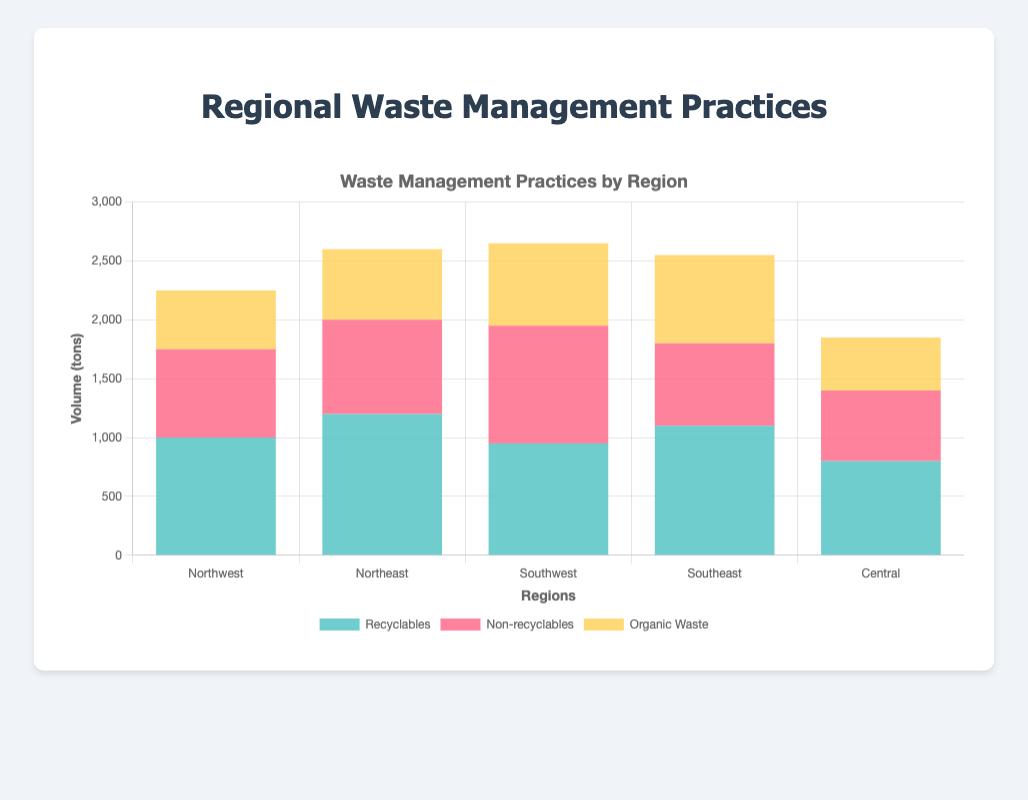Which region has the highest volume of recyclables? The Northeast region has the highest volume of recyclables. This can be seen by comparing the height of the sections colored for recyclables in each bar, with the Northeast having the tallest section.
Answer: Northeast Which region has the lowest volume of non-recyclables? The Central region has the lowest volume of non-recyclables. This is observed by noting that the section colored for non-recyclables in the Central region is shorter than in other regions.
Answer: Central What is the total volume of waste (all types) in the Southwest region? In the Southwest region, the total volume is computed as follows: Recyclables (950 tons) + Non-recyclables (1000 tons) + Organic Waste (700 tons) = 2650 tons.
Answer: 2650 tons How much more recyclables volume is there in the Northeast compared to the Central region? The volume of recyclables in the Northeast is 1200 tons, and in the Central region, it is 800 tons. Therefore, the difference is 1200 - 800 = 400 tons.
Answer: 400 tons Which region has the highest total volume of organic waste, and what is that volume? The Southeast region has the highest volume of organic waste, which is observed by the height of the organic waste section, and it is 750 tons.
Answer: Southeast, 750 tons Compare the volume of non-recyclables in the Northwest and Southwest regions. Which one is higher and by how much? The volume of non-recyclables in the Northwest is 750 tons, and in the Southwest, it is 1000 tons. The Southwest has a higher volume by 1000 - 750 = 250 tons.
Answer: Southwest, 250 tons What is the average volume of organic waste across all regions? The volumes of organic waste are: 500 (Northwest), 600 (Northeast), 700 (Southwest), 750 (Southeast), and 450 (Central). The total is 500+600+700+750+450 = 3000 tons, so the average is 3000 / 5 = 600 tons.
Answer: 600 tons Between which two regions is the total waste volume the most similar, and what are their respective volumes? The most similar total waste volumes are in the Northwest (1000+750+500 = 2250 tons) and the Southeast (1100+700+750 = 2550 tons). The difference is 2550 - 2250 = 300 tons, the smallest difference when comparing all pairs.
Answer: Northwest (2250 tons) and Southeast (2550 tons) What is the difference in total waste volume between the highest and the lowest generating regions? The highest volume is in the Southeast (2550 tons), and the lowest is in the Central (1850 tons). The difference is 2550 - 1850 = 700 tons.
Answer: 700 tons 